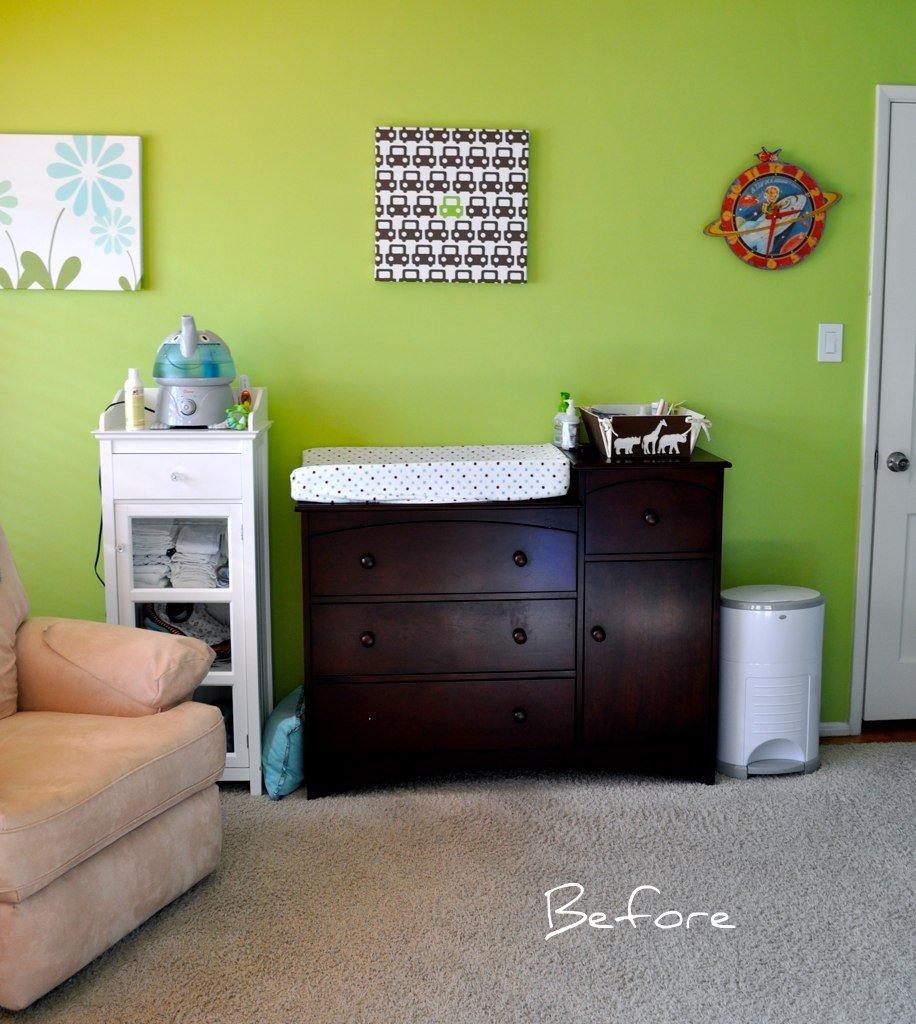What time does the clock say?
Offer a terse response. 2:31. What is on the bottom right?
Your response must be concise. Before. 